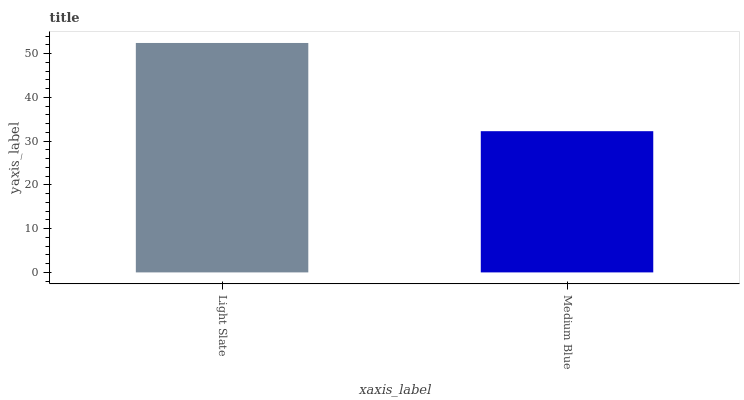Is Medium Blue the minimum?
Answer yes or no. Yes. Is Light Slate the maximum?
Answer yes or no. Yes. Is Medium Blue the maximum?
Answer yes or no. No. Is Light Slate greater than Medium Blue?
Answer yes or no. Yes. Is Medium Blue less than Light Slate?
Answer yes or no. Yes. Is Medium Blue greater than Light Slate?
Answer yes or no. No. Is Light Slate less than Medium Blue?
Answer yes or no. No. Is Light Slate the high median?
Answer yes or no. Yes. Is Medium Blue the low median?
Answer yes or no. Yes. Is Medium Blue the high median?
Answer yes or no. No. Is Light Slate the low median?
Answer yes or no. No. 